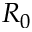Convert formula to latex. <formula><loc_0><loc_0><loc_500><loc_500>R _ { 0 }</formula> 